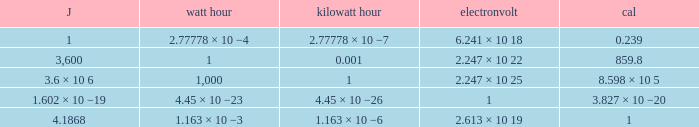How many calories is 1 watt hour? 859.8. 